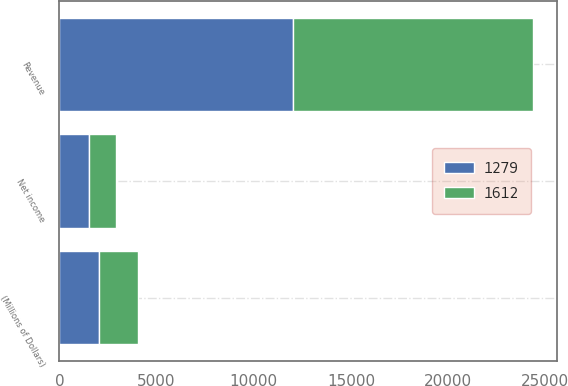Convert chart. <chart><loc_0><loc_0><loc_500><loc_500><stacked_bar_chart><ecel><fcel>(Millions of Dollars)<fcel>Revenue<fcel>Net income<nl><fcel>1612<fcel>2018<fcel>12337<fcel>1382<nl><fcel>1279<fcel>2017<fcel>12033<fcel>1525<nl></chart> 